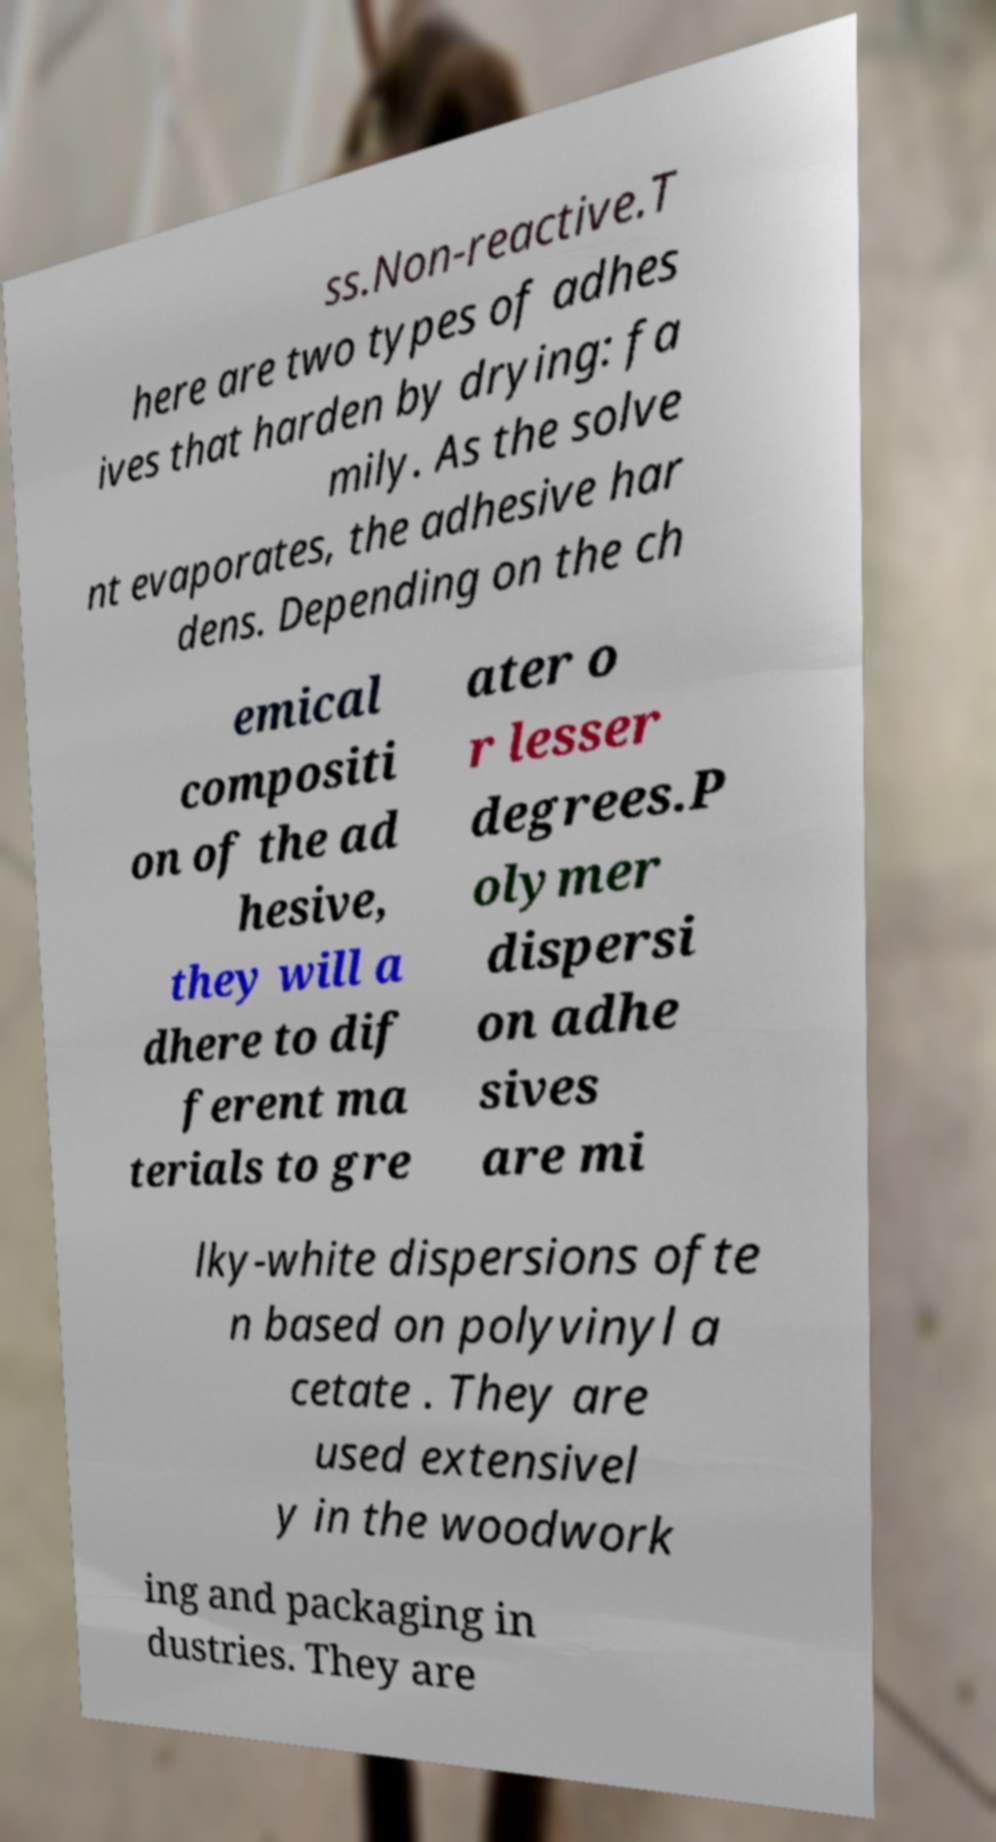Can you read and provide the text displayed in the image?This photo seems to have some interesting text. Can you extract and type it out for me? ss.Non-reactive.T here are two types of adhes ives that harden by drying: fa mily. As the solve nt evaporates, the adhesive har dens. Depending on the ch emical compositi on of the ad hesive, they will a dhere to dif ferent ma terials to gre ater o r lesser degrees.P olymer dispersi on adhe sives are mi lky-white dispersions ofte n based on polyvinyl a cetate . They are used extensivel y in the woodwork ing and packaging in dustries. They are 